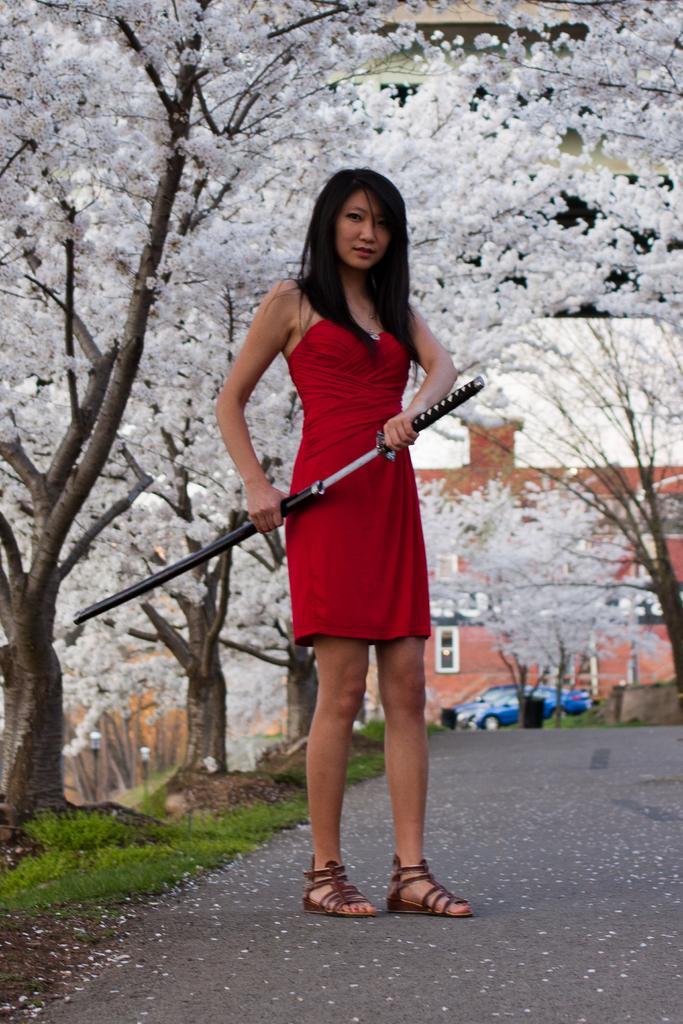How would you summarize this image in a sentence or two? In this picture there is a girl who is wearing white dress and holding a sword. She is standing on the road. Here we can see many trees, on that we can see white color leaves or flowers. On the bottom left corner we can see grass. In the background there is a blue color car standing near to the building. Here it's a sky. 